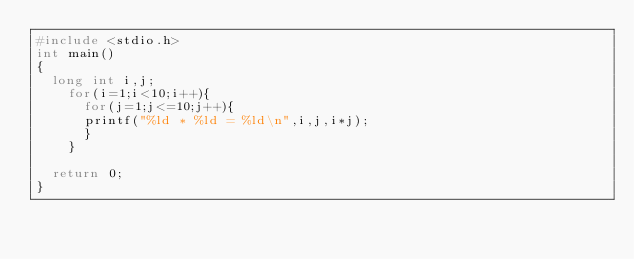Convert code to text. <code><loc_0><loc_0><loc_500><loc_500><_C++_>#include <stdio.h>
int main()
{
	long int i,j;
		for(i=1;i<10;i++){
			for(j=1;j<=10;j++){
			printf("%ld * %ld = %ld\n",i,j,i*j);
			}
		}

	return 0;
}</code> 